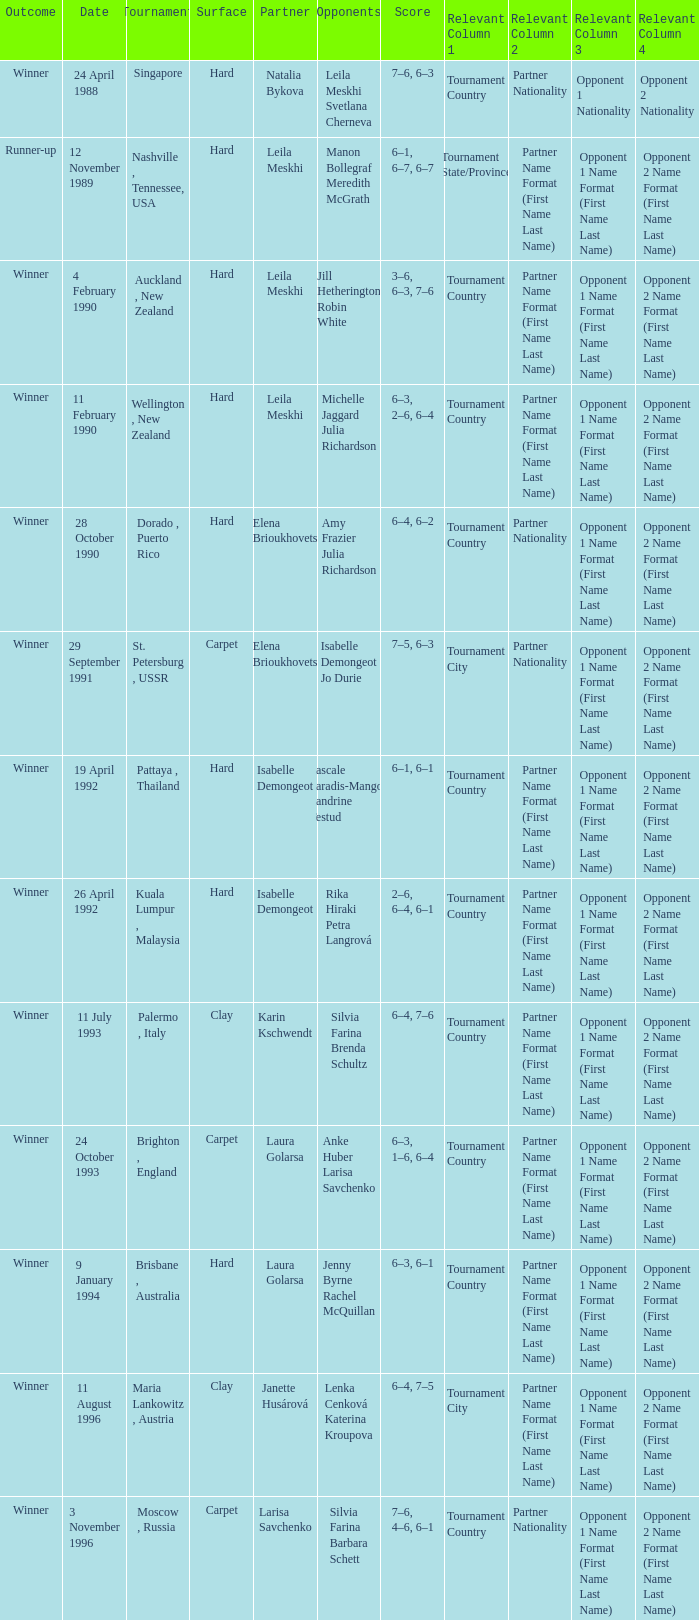Could you help me parse every detail presented in this table? {'header': ['Outcome', 'Date', 'Tournament', 'Surface', 'Partner', 'Opponents', 'Score', 'Relevant Column 1', 'Relevant Column 2', 'Relevant Column 3', 'Relevant Column 4'], 'rows': [['Winner', '24 April 1988', 'Singapore', 'Hard', 'Natalia Bykova', 'Leila Meskhi Svetlana Cherneva', '7–6, 6–3', 'Tournament Country', 'Partner Nationality', 'Opponent 1 Nationality', 'Opponent 2 Nationality '], ['Runner-up', '12 November 1989', 'Nashville , Tennessee, USA', 'Hard', 'Leila Meskhi', 'Manon Bollegraf Meredith McGrath', '6–1, 6–7, 6–7', 'Tournament State/Province', 'Partner Name Format (First Name Last Name)', 'Opponent 1 Name Format (First Name Last Name)', 'Opponent 2 Name Format (First Name Last Name)'], ['Winner', '4 February 1990', 'Auckland , New Zealand', 'Hard', 'Leila Meskhi', 'Jill Hetherington Robin White', '3–6, 6–3, 7–6', 'Tournament Country', 'Partner Name Format (First Name Last Name)', 'Opponent 1 Name Format (First Name Last Name)', 'Opponent 2 Name Format (First Name Last Name)'], ['Winner', '11 February 1990', 'Wellington , New Zealand', 'Hard', 'Leila Meskhi', 'Michelle Jaggard Julia Richardson', '6–3, 2–6, 6–4', 'Tournament Country', 'Partner Name Format (First Name Last Name)', 'Opponent 1 Name Format (First Name Last Name)', 'Opponent 2 Name Format (First Name Last Name)'], ['Winner', '28 October 1990', 'Dorado , Puerto Rico', 'Hard', 'Elena Brioukhovets', 'Amy Frazier Julia Richardson', '6–4, 6–2', 'Tournament Country', 'Partner Nationality', 'Opponent 1 Name Format (First Name Last Name)', 'Opponent 2 Name Format (First Name Last Name)'], ['Winner', '29 September 1991', 'St. Petersburg , USSR', 'Carpet', 'Elena Brioukhovets', 'Isabelle Demongeot Jo Durie', '7–5, 6–3', 'Tournament City', 'Partner Nationality', 'Opponent 1 Name Format (First Name Last Name)', 'Opponent 2 Name Format (First Name Last Name)'], ['Winner', '19 April 1992', 'Pattaya , Thailand', 'Hard', 'Isabelle Demongeot', 'Pascale Paradis-Mangon Sandrine Testud', '6–1, 6–1', 'Tournament Country', 'Partner Name Format (First Name Last Name)', 'Opponent 1 Name Format (First Name Last Name)', 'Opponent 2 Name Format (First Name Last Name)'], ['Winner', '26 April 1992', 'Kuala Lumpur , Malaysia', 'Hard', 'Isabelle Demongeot', 'Rika Hiraki Petra Langrová', '2–6, 6–4, 6–1', 'Tournament Country', 'Partner Name Format (First Name Last Name)', 'Opponent 1 Name Format (First Name Last Name)', 'Opponent 2 Name Format (First Name Last Name)'], ['Winner', '11 July 1993', 'Palermo , Italy', 'Clay', 'Karin Kschwendt', 'Silvia Farina Brenda Schultz', '6–4, 7–6', 'Tournament Country', 'Partner Name Format (First Name Last Name)', 'Opponent 1 Name Format (First Name Last Name)', 'Opponent 2 Name Format (First Name Last Name)'], ['Winner', '24 October 1993', 'Brighton , England', 'Carpet', 'Laura Golarsa', 'Anke Huber Larisa Savchenko', '6–3, 1–6, 6–4', 'Tournament Country', 'Partner Name Format (First Name Last Name)', 'Opponent 1 Name Format (First Name Last Name)', 'Opponent 2 Name Format (First Name Last Name)'], ['Winner', '9 January 1994', 'Brisbane , Australia', 'Hard', 'Laura Golarsa', 'Jenny Byrne Rachel McQuillan', '6–3, 6–1', 'Tournament Country', 'Partner Name Format (First Name Last Name)', 'Opponent 1 Name Format (First Name Last Name)', 'Opponent 2 Name Format (First Name Last Name)'], ['Winner', '11 August 1996', 'Maria Lankowitz , Austria', 'Clay', 'Janette Husárová', 'Lenka Cenková Katerina Kroupova', '6–4, 7–5', 'Tournament City', 'Partner Name Format (First Name Last Name)', 'Opponent 1 Name Format (First Name Last Name)', 'Opponent 2 Name Format (First Name Last Name)'], ['Winner', '3 November 1996', 'Moscow , Russia', 'Carpet', 'Larisa Savchenko', 'Silvia Farina Barbara Schett', '7–6, 4–6, 6–1', 'Tournament Country', 'Partner Nationality', 'Opponent 1 Name Format (First Name Last Name)', 'Opponent 2 Name Format (First Name Last Name)']]} Who was the Partner in a game with the Score of 6–4, 6–2 on a hard surface? Elena Brioukhovets. 